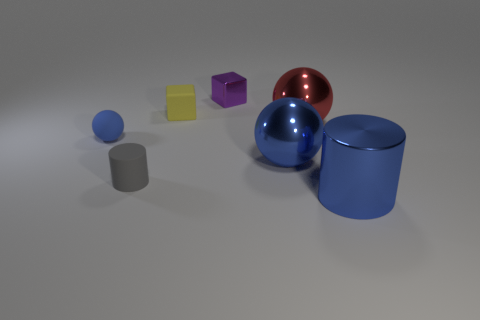What does the large red sphere represent? The large red sphere can represent multiple concepts; visually, it stands out due to its vibrant color and size. It may symbolize unity or completeness, or simply offer a contrast in color and form to the other objects. 